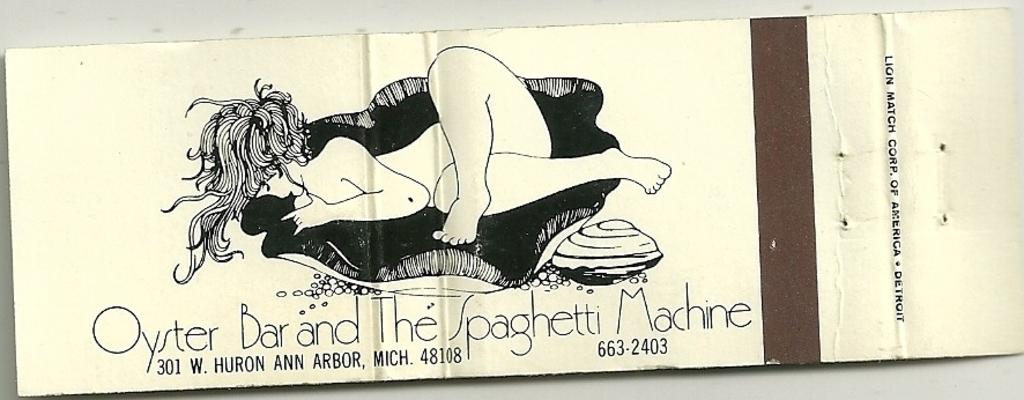What is featured on the poster in the image? The poster in the image contains text and a drawing of a person. Can you describe the drawing on the poster? The drawing on the poster is of a person. What is the purpose of the text on the poster? The purpose of the text on the poster is not specified in the facts provided. How many cards are being fanned out by the person in the drawing on the poster? There is no mention of cards or a fan in the image, and the drawing on the poster does not depict a person fanning out cards. 